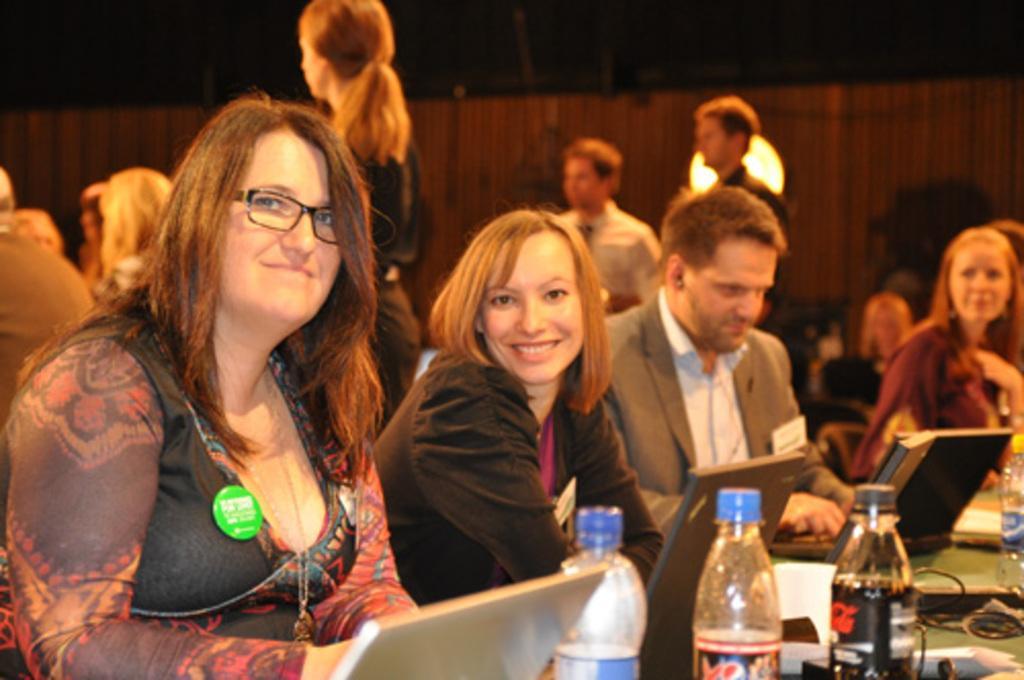Can you describe this image briefly? In this image we can see people sitting on chairs. There are objects on the table. In the background of the image there is wooden wall. 